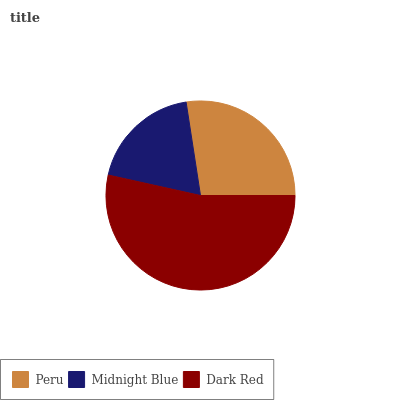Is Midnight Blue the minimum?
Answer yes or no. Yes. Is Dark Red the maximum?
Answer yes or no. Yes. Is Dark Red the minimum?
Answer yes or no. No. Is Midnight Blue the maximum?
Answer yes or no. No. Is Dark Red greater than Midnight Blue?
Answer yes or no. Yes. Is Midnight Blue less than Dark Red?
Answer yes or no. Yes. Is Midnight Blue greater than Dark Red?
Answer yes or no. No. Is Dark Red less than Midnight Blue?
Answer yes or no. No. Is Peru the high median?
Answer yes or no. Yes. Is Peru the low median?
Answer yes or no. Yes. Is Midnight Blue the high median?
Answer yes or no. No. Is Midnight Blue the low median?
Answer yes or no. No. 